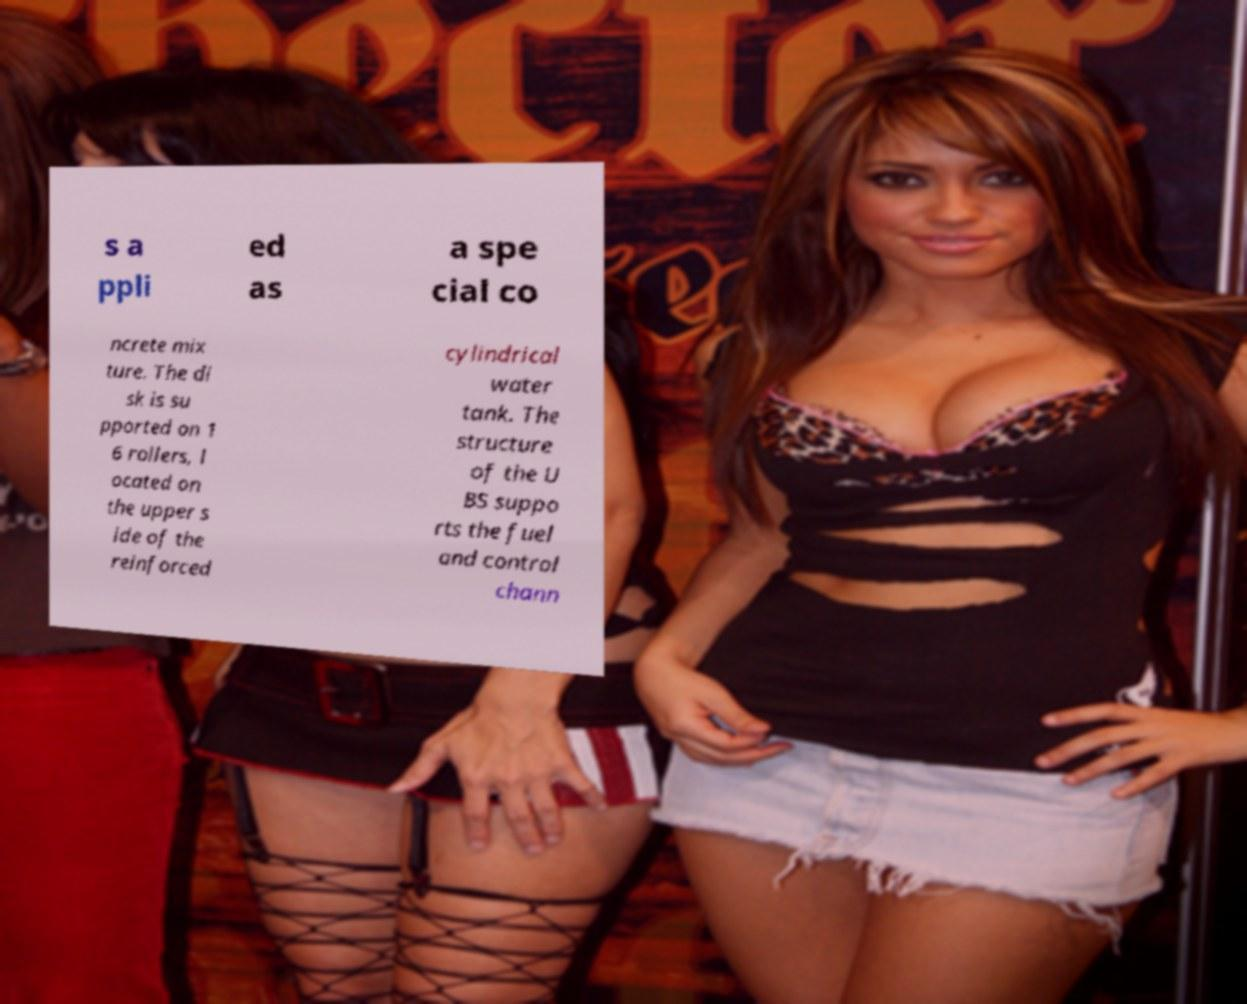Please read and relay the text visible in this image. What does it say? s a ppli ed as a spe cial co ncrete mix ture. The di sk is su pported on 1 6 rollers, l ocated on the upper s ide of the reinforced cylindrical water tank. The structure of the U BS suppo rts the fuel and control chann 